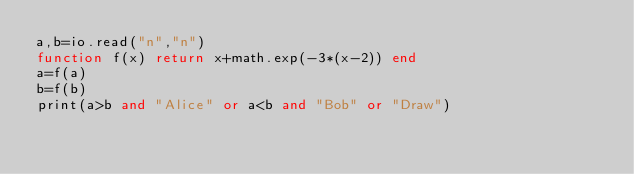<code> <loc_0><loc_0><loc_500><loc_500><_Lua_>a,b=io.read("n","n")
function f(x) return x+math.exp(-3*(x-2)) end
a=f(a)
b=f(b)
print(a>b and "Alice" or a<b and "Bob" or "Draw")</code> 